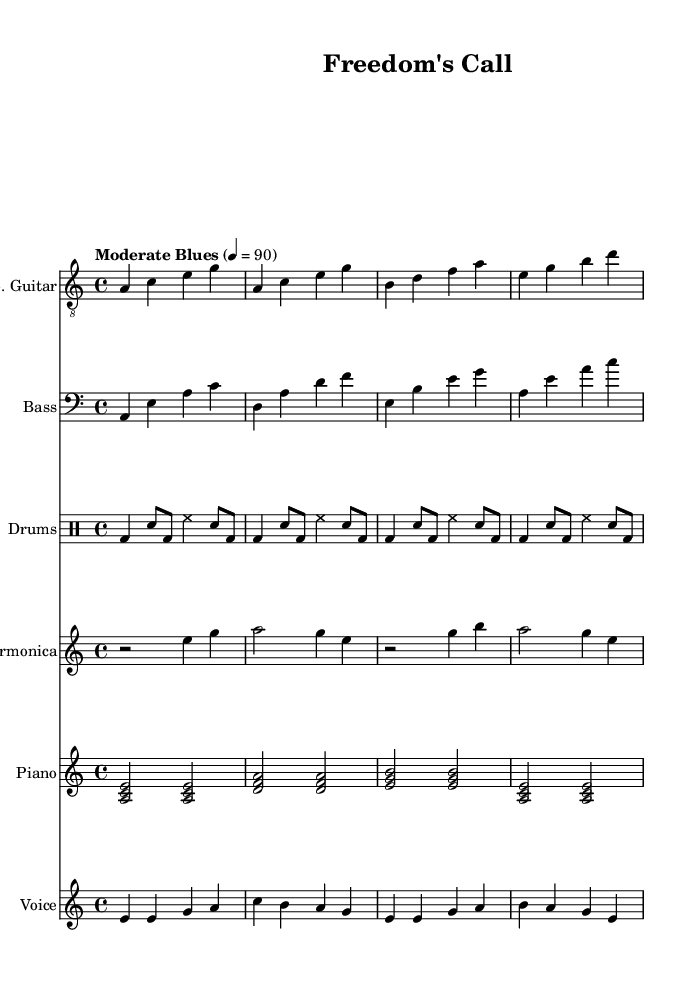What is the key signature of this music? The key signature is indicated at the beginning of the staff, and it shows one flat, which signifies that the key is A minor.
Answer: A minor What is the time signature of this music? The time signature is located at the beginning of the score, shown as 4/4, indicating that there are four beats in each measure and that the quarter note gets one beat.
Answer: 4/4 What is the tempo marking for this piece? The tempo is labeled above the staff and indicates "Moderate Blues" with a metronome marking of 90 beats per minute, suggesting a moderately paced performance typical of Blues music.
Answer: Moderately Blues 4 = 90 How many measures are in the melody section? By counting the phrases in the melody line, we note that there are four distinct measures shown within the melody section, each separated by a bar line.
Answer: 4 What instrument plays the harmony in this music? The harmony in this piece is provided by the piano, as indicated by the staff labeled "Piano" and the chords written in that staff.
Answer: Piano What is the significance of the lyrics included in the score? The lyrics reflect a protest theme relevant to the Blues genre, particularly to the 1960s Chicago Blues movement, emphasizing the call for freedom and justice in the context of social unrest.
Answer: Protest theme What is the predominant stylistic characteristic of this piece of music? This piece blends traditional Blues elements (like the use of electric guitar, harmonica, and the 12-bar structure) with historical themes of protest, which is a key feature of the 1960s Chicago Blues scene.
Answer: Blues fusion 